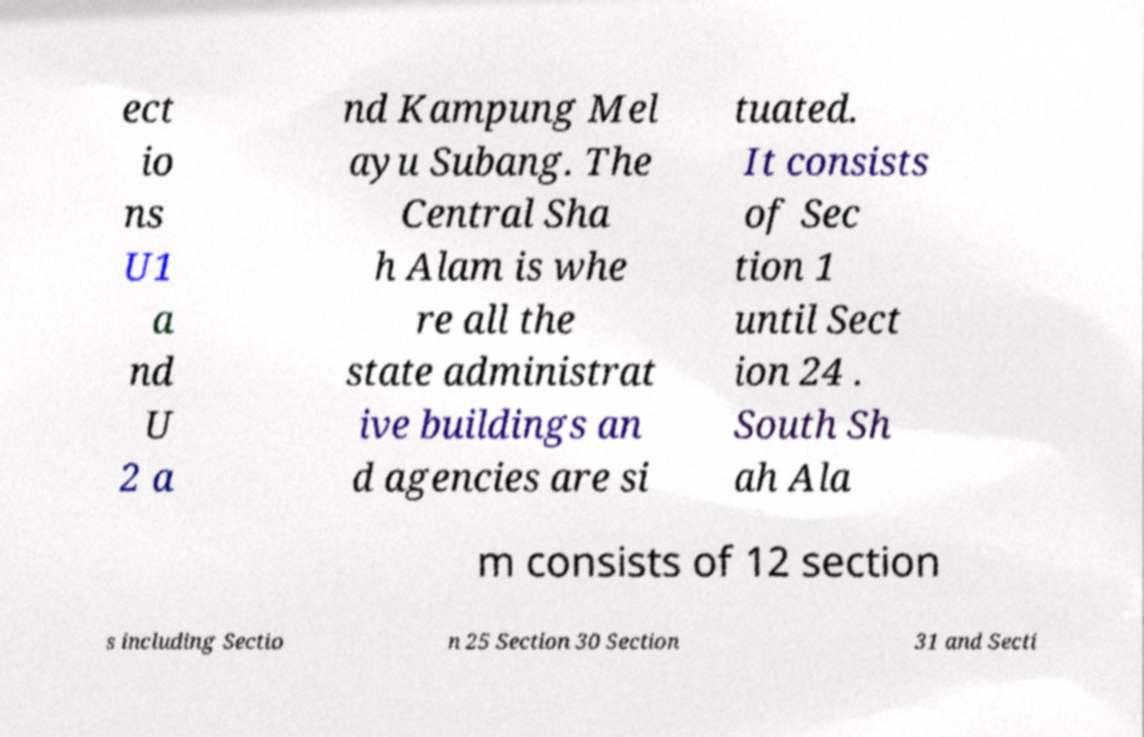Could you extract and type out the text from this image? ect io ns U1 a nd U 2 a nd Kampung Mel ayu Subang. The Central Sha h Alam is whe re all the state administrat ive buildings an d agencies are si tuated. It consists of Sec tion 1 until Sect ion 24 . South Sh ah Ala m consists of 12 section s including Sectio n 25 Section 30 Section 31 and Secti 